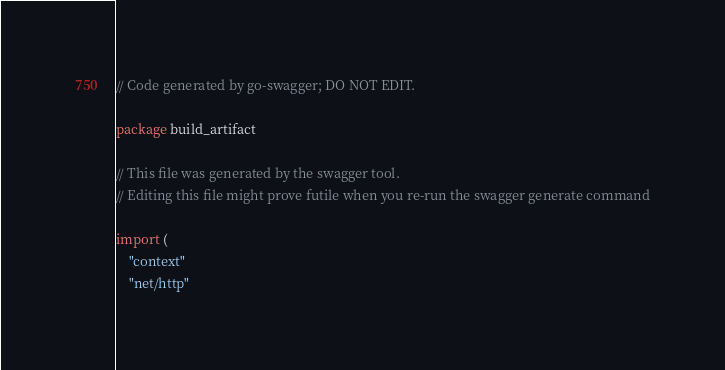<code> <loc_0><loc_0><loc_500><loc_500><_Go_>// Code generated by go-swagger; DO NOT EDIT.

package build_artifact

// This file was generated by the swagger tool.
// Editing this file might prove futile when you re-run the swagger generate command

import (
	"context"
	"net/http"</code> 